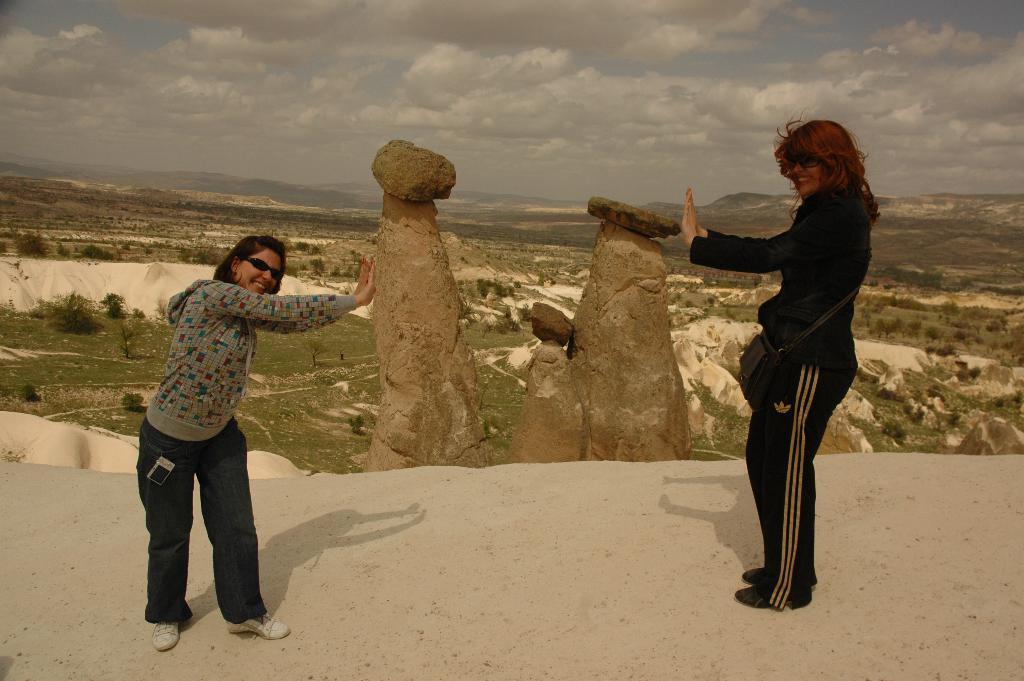How would you summarize this image in a sentence or two? In this picture we can see there are two people standing on the path. Behind the people there are rocks, hills and the sky. 